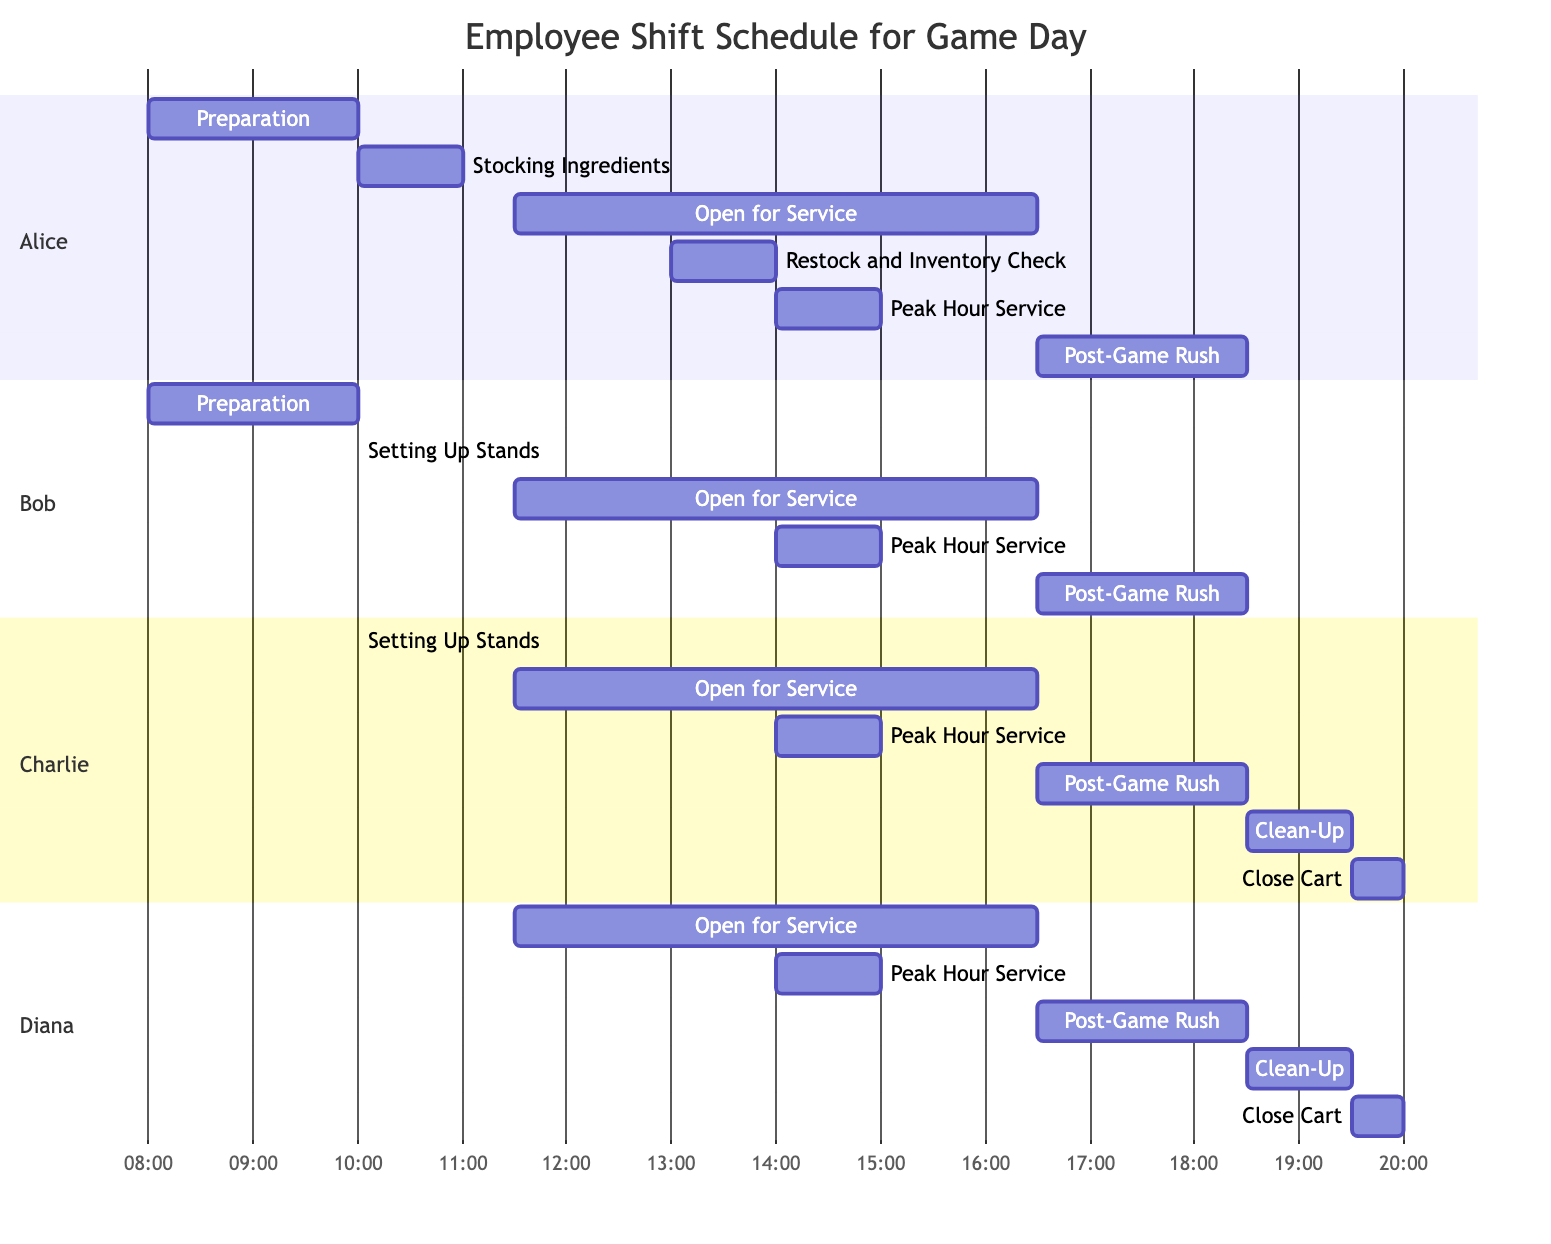What time does the "Peak Hour Service" start? The "Peak Hour Service" task starts at 14:00 as indicated in the diagram.
Answer: 14:00 Who is assigned to the "Clean-Up" task? The "Clean-Up" task is assigned to Charlie and Diana, as shown in the list of assigned employees for that task.
Answer: Charlie, Diana How long is the "Open for Service" task? The "Open for Service" task lasts from 11:30 to 16:30, which is a total of 5 hours, as confirmed by the start and end times.
Answer: 5 hours What is the last task in the schedule? The last task in the schedule is "Close Cart," which is listed last in the diagram following the "Clean-Up" task.
Answer: Close Cart Which two employees are busy during the "Setting Up Stands" task? The "Setting Up Stands" task is assigned to Bob and Charlie, as indicated in the assigned employee list for that task.
Answer: Bob, Charlie What is the duration of "Preparation"? "Preparation" starts at 08:00 and ends at 10:00, which makes the duration 2 hours, as it is calculated from the start and end time.
Answer: 2 hours How many employees are working during the "Post-Game Rush"? During the "Post-Game Rush" task, there are four employees assigned: Alice, Bob, Charlie, and Diana.
Answer: Four What task overlaps with "Restock and Inventory Check"? The task that overlaps with "Restock and Inventory Check" is "Open for Service," as "Restock" starts at 13:00 while "Open for Service" continues until 16:30.
Answer: Open for Service How many tasks are assigned to Alice? Alice is assigned to six tasks: "Preparation," "Stocking Ingredients," "Open for Service," "Restock and Inventory Check," "Peak Hour Service," and "Post-Game Rush."
Answer: Six 